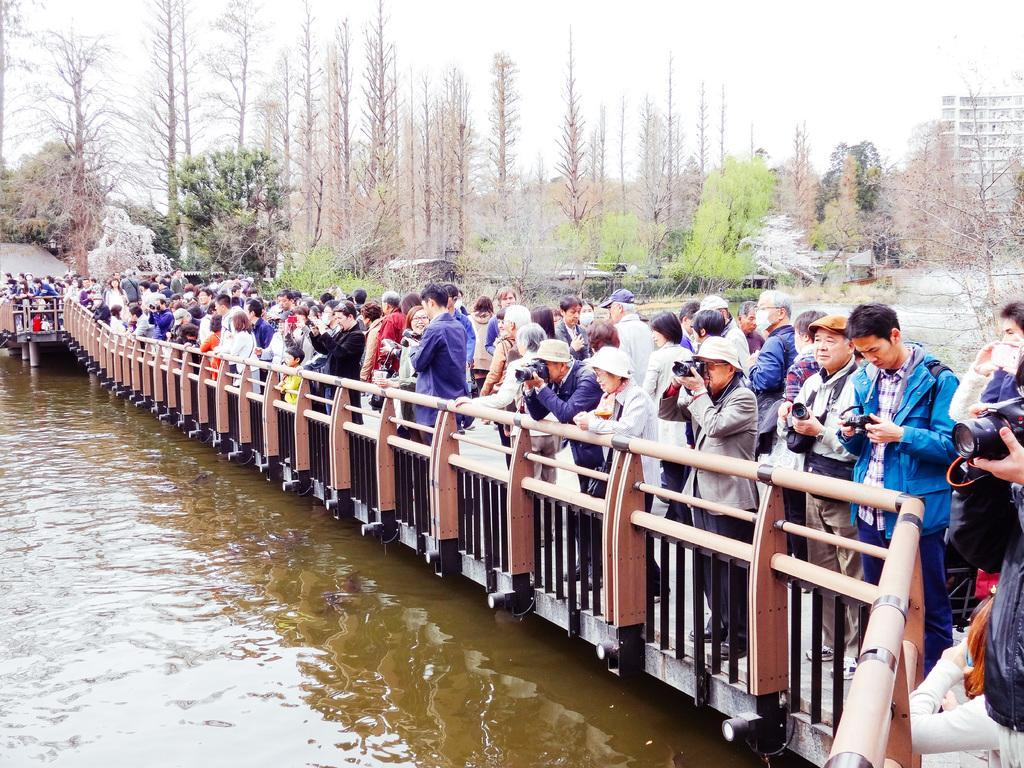In one or two sentences, can you explain what this image depicts? In this picture we can see group of people, few people holding cameras and they are all standing on the bridge, on the left side of the image we can see water, in the background we can find few trees and a building. 